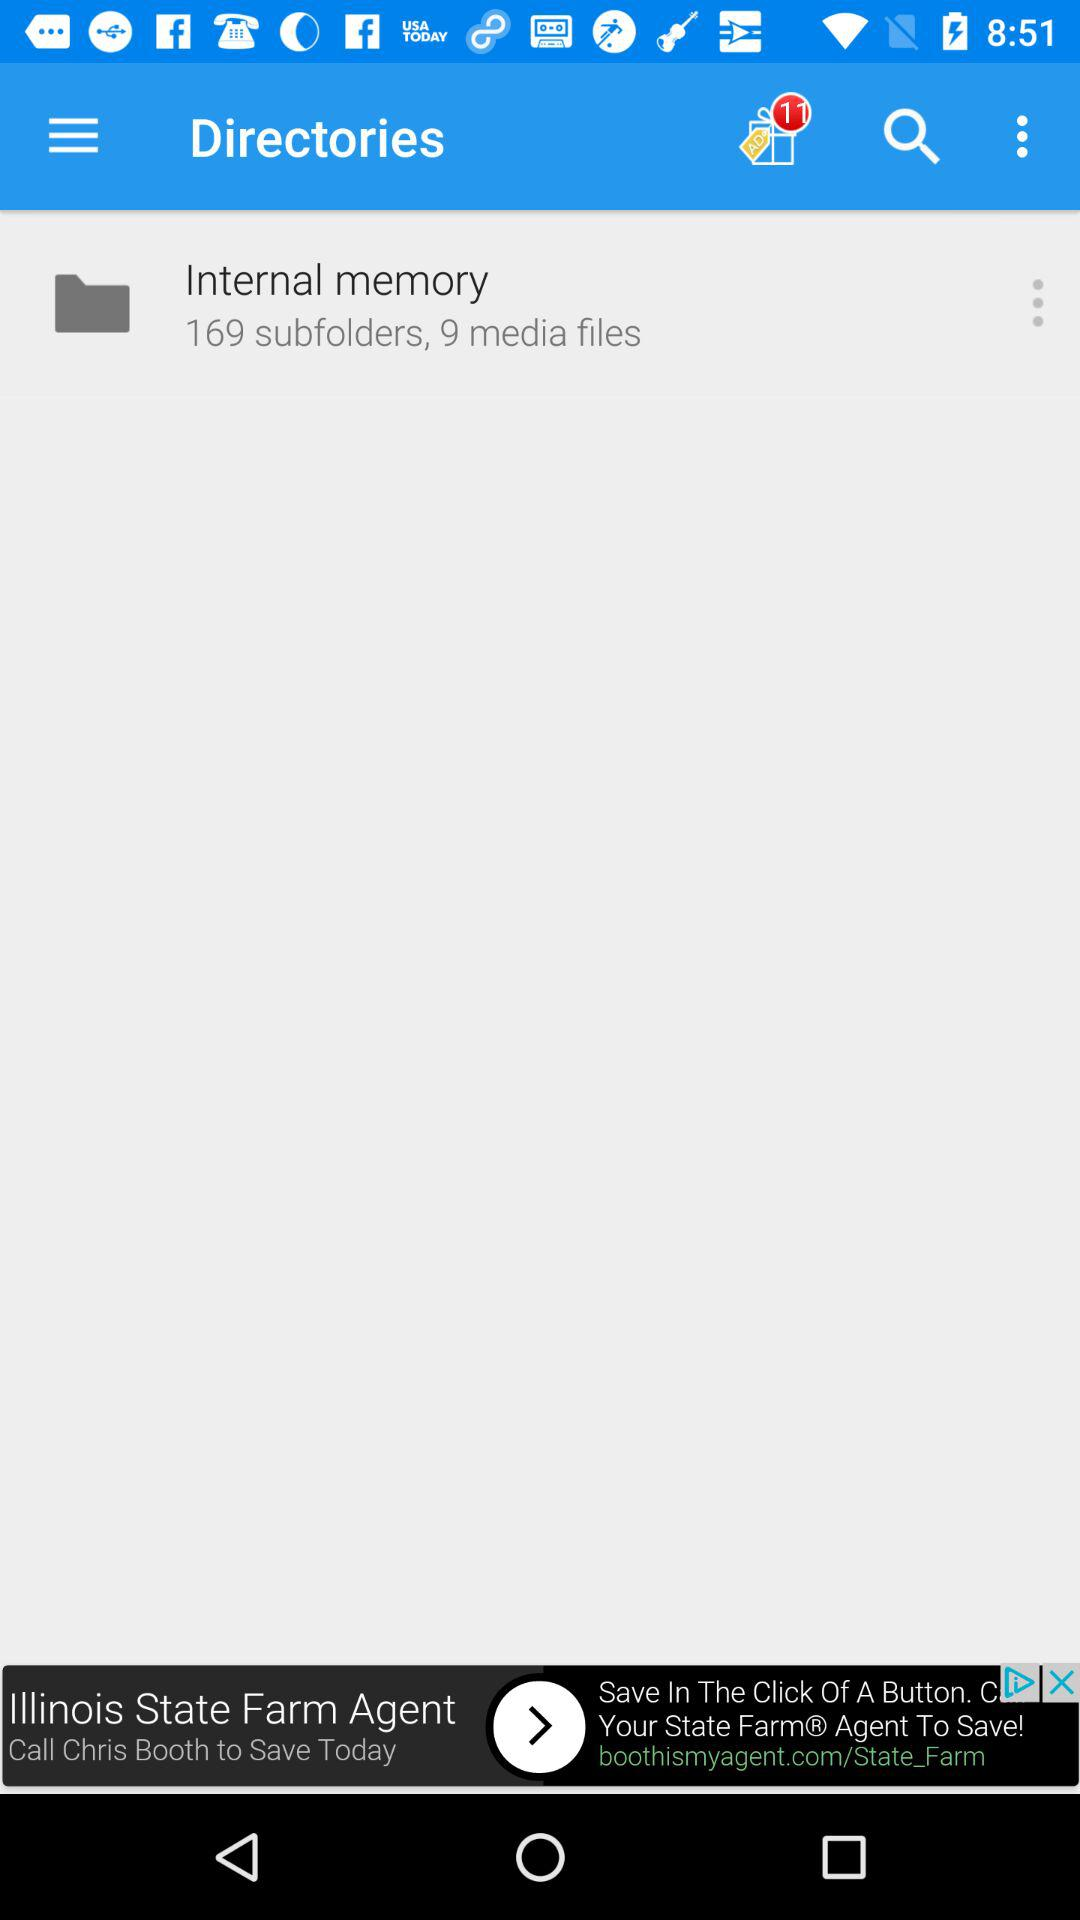What is the count of ad notifications? The count of ad notifications is 11. 